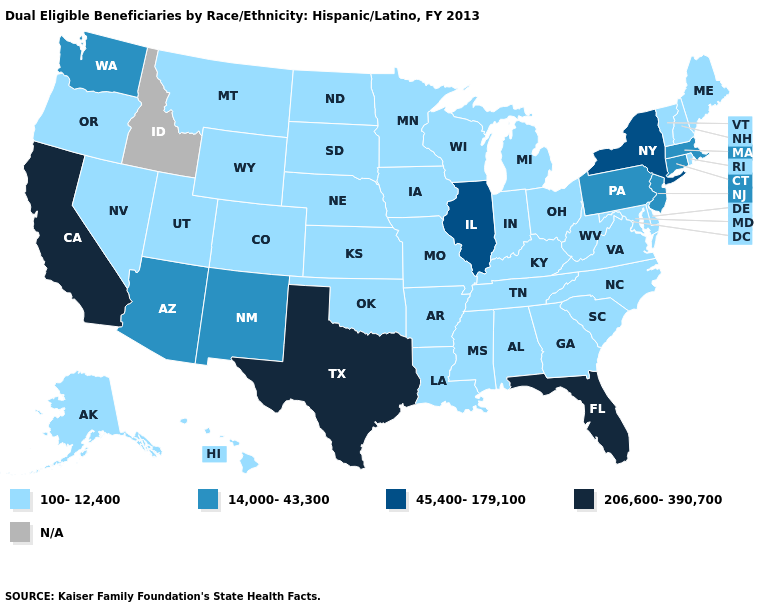Name the states that have a value in the range 206,600-390,700?
Answer briefly. California, Florida, Texas. What is the value of New Jersey?
Be succinct. 14,000-43,300. What is the value of Alaska?
Write a very short answer. 100-12,400. Name the states that have a value in the range 45,400-179,100?
Short answer required. Illinois, New York. Name the states that have a value in the range 45,400-179,100?
Quick response, please. Illinois, New York. Name the states that have a value in the range N/A?
Short answer required. Idaho. Name the states that have a value in the range 14,000-43,300?
Short answer required. Arizona, Connecticut, Massachusetts, New Jersey, New Mexico, Pennsylvania, Washington. Does Arizona have the lowest value in the USA?
Answer briefly. No. Name the states that have a value in the range 45,400-179,100?
Quick response, please. Illinois, New York. Name the states that have a value in the range 100-12,400?
Answer briefly. Alabama, Alaska, Arkansas, Colorado, Delaware, Georgia, Hawaii, Indiana, Iowa, Kansas, Kentucky, Louisiana, Maine, Maryland, Michigan, Minnesota, Mississippi, Missouri, Montana, Nebraska, Nevada, New Hampshire, North Carolina, North Dakota, Ohio, Oklahoma, Oregon, Rhode Island, South Carolina, South Dakota, Tennessee, Utah, Vermont, Virginia, West Virginia, Wisconsin, Wyoming. Which states have the highest value in the USA?
Keep it brief. California, Florida, Texas. Name the states that have a value in the range N/A?
Short answer required. Idaho. Does Illinois have the highest value in the MidWest?
Be succinct. Yes. Name the states that have a value in the range N/A?
Concise answer only. Idaho. Name the states that have a value in the range 100-12,400?
Give a very brief answer. Alabama, Alaska, Arkansas, Colorado, Delaware, Georgia, Hawaii, Indiana, Iowa, Kansas, Kentucky, Louisiana, Maine, Maryland, Michigan, Minnesota, Mississippi, Missouri, Montana, Nebraska, Nevada, New Hampshire, North Carolina, North Dakota, Ohio, Oklahoma, Oregon, Rhode Island, South Carolina, South Dakota, Tennessee, Utah, Vermont, Virginia, West Virginia, Wisconsin, Wyoming. 